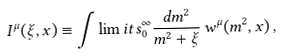<formula> <loc_0><loc_0><loc_500><loc_500>I ^ { \mu } ( \xi , x ) \equiv \int \lim i t s ^ { \infty } _ { 0 } \frac { d m ^ { 2 } } { m ^ { 2 } + \xi } \, w ^ { \mu } ( m ^ { 2 } , x ) \, ,</formula> 